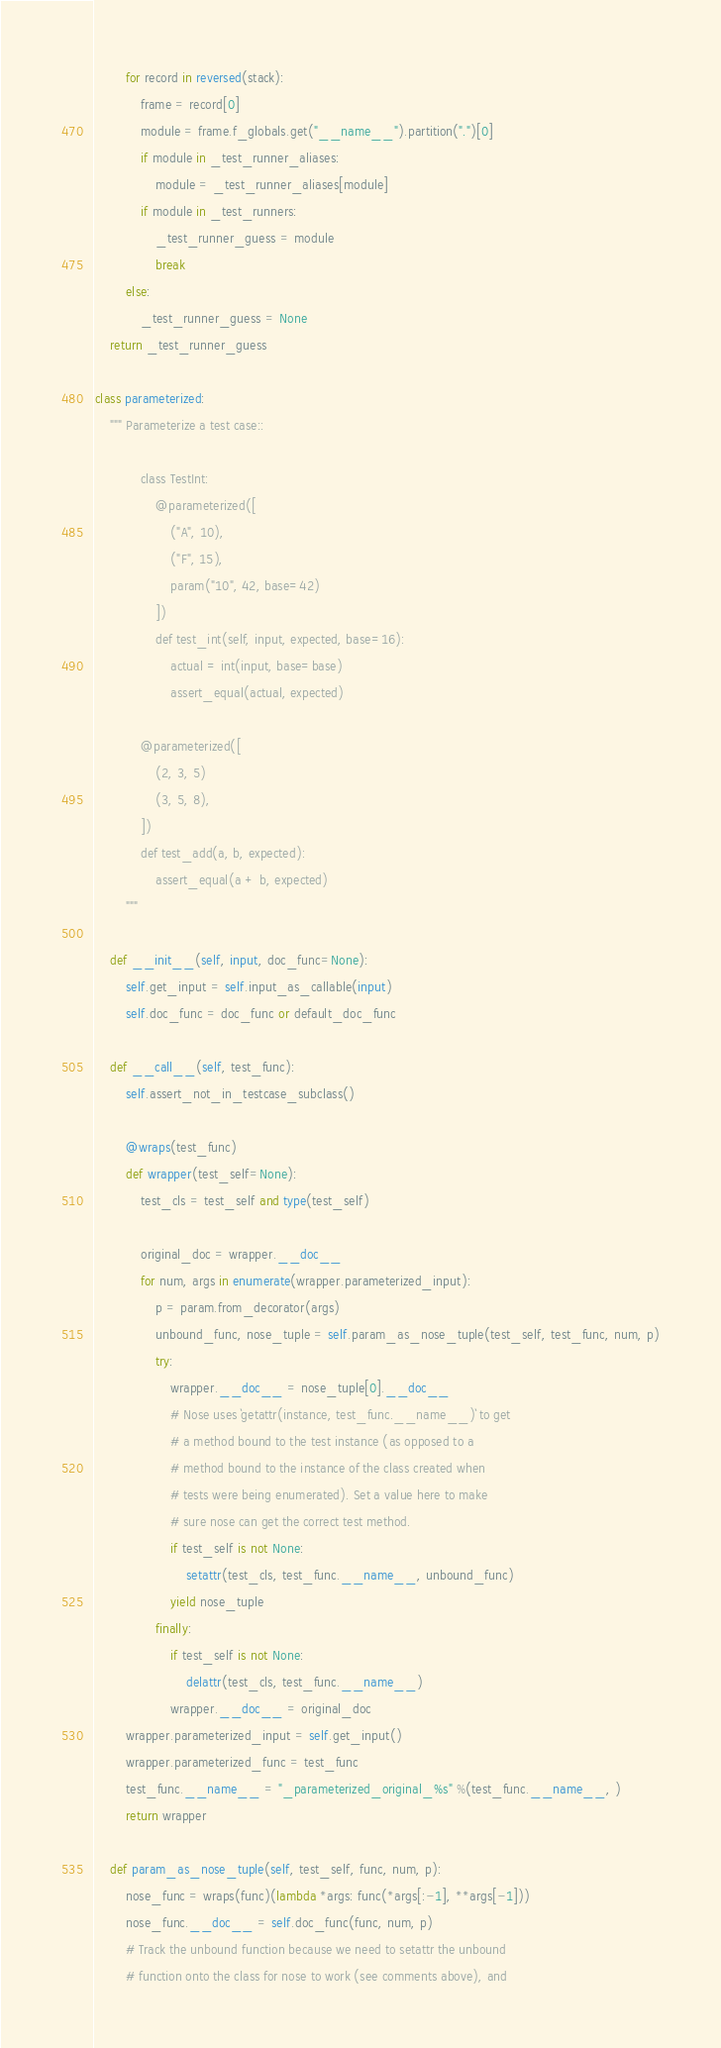<code> <loc_0><loc_0><loc_500><loc_500><_Python_>        for record in reversed(stack):
            frame = record[0]
            module = frame.f_globals.get("__name__").partition(".")[0]
            if module in _test_runner_aliases:
                module = _test_runner_aliases[module]
            if module in _test_runners:
                _test_runner_guess = module
                break
        else:
            _test_runner_guess = None
    return _test_runner_guess

class parameterized:
    """ Parameterize a test case::

            class TestInt:
                @parameterized([
                    ("A", 10),
                    ("F", 15),
                    param("10", 42, base=42)
                ])
                def test_int(self, input, expected, base=16):
                    actual = int(input, base=base)
                    assert_equal(actual, expected)

            @parameterized([
                (2, 3, 5)
                (3, 5, 8),
            ])
            def test_add(a, b, expected):
                assert_equal(a + b, expected)
        """

    def __init__(self, input, doc_func=None):
        self.get_input = self.input_as_callable(input)
        self.doc_func = doc_func or default_doc_func

    def __call__(self, test_func):
        self.assert_not_in_testcase_subclass()

        @wraps(test_func)
        def wrapper(test_self=None):
            test_cls = test_self and type(test_self)

            original_doc = wrapper.__doc__
            for num, args in enumerate(wrapper.parameterized_input):
                p = param.from_decorator(args)
                unbound_func, nose_tuple = self.param_as_nose_tuple(test_self, test_func, num, p)
                try:
                    wrapper.__doc__ = nose_tuple[0].__doc__
                    # Nose uses `getattr(instance, test_func.__name__)` to get
                    # a method bound to the test instance (as opposed to a
                    # method bound to the instance of the class created when
                    # tests were being enumerated). Set a value here to make
                    # sure nose can get the correct test method.
                    if test_self is not None:
                        setattr(test_cls, test_func.__name__, unbound_func)
                    yield nose_tuple
                finally:
                    if test_self is not None:
                        delattr(test_cls, test_func.__name__)
                    wrapper.__doc__ = original_doc
        wrapper.parameterized_input = self.get_input()
        wrapper.parameterized_func = test_func
        test_func.__name__ = "_parameterized_original_%s" %(test_func.__name__, )
        return wrapper

    def param_as_nose_tuple(self, test_self, func, num, p):
        nose_func = wraps(func)(lambda *args: func(*args[:-1], **args[-1]))
        nose_func.__doc__ = self.doc_func(func, num, p)
        # Track the unbound function because we need to setattr the unbound
        # function onto the class for nose to work (see comments above), and</code> 